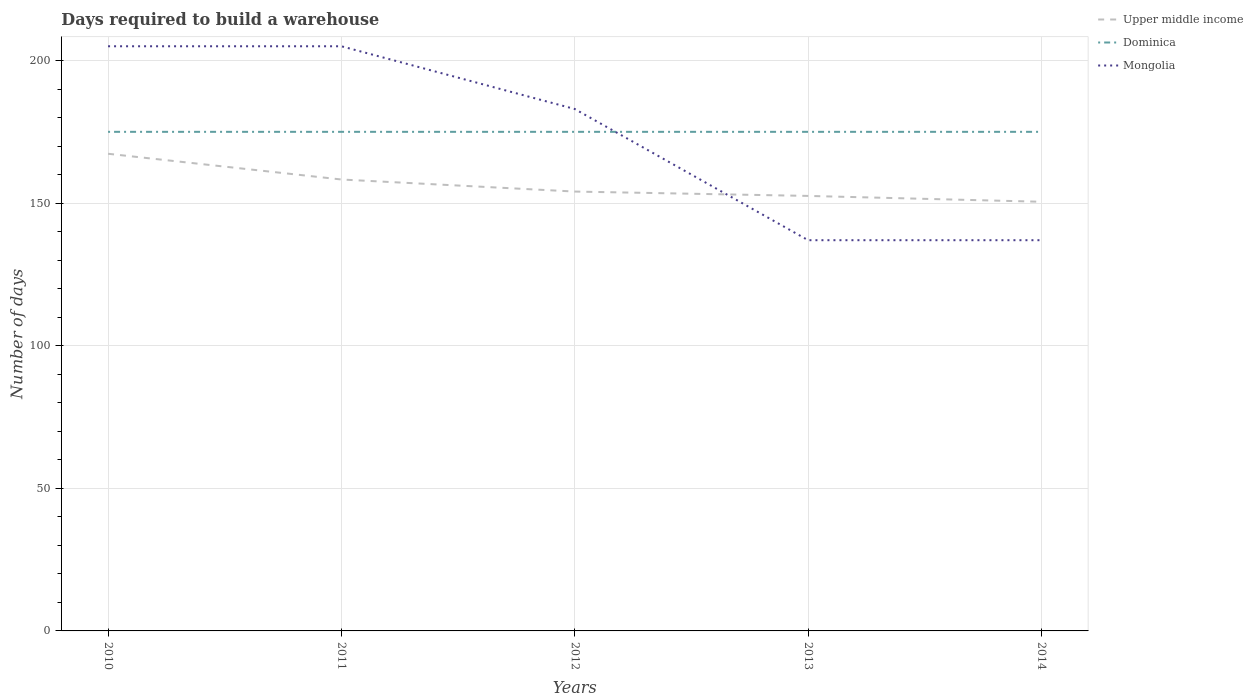How many different coloured lines are there?
Your response must be concise. 3. Does the line corresponding to Upper middle income intersect with the line corresponding to Mongolia?
Offer a terse response. Yes. Is the number of lines equal to the number of legend labels?
Keep it short and to the point. Yes. Across all years, what is the maximum days required to build a warehouse in in Upper middle income?
Give a very brief answer. 150.48. What is the total days required to build a warehouse in in Mongolia in the graph?
Give a very brief answer. 68. Is the days required to build a warehouse in in Dominica strictly greater than the days required to build a warehouse in in Upper middle income over the years?
Offer a terse response. No. How many lines are there?
Your answer should be very brief. 3. How many years are there in the graph?
Give a very brief answer. 5. What is the difference between two consecutive major ticks on the Y-axis?
Your answer should be compact. 50. Does the graph contain any zero values?
Give a very brief answer. No. Where does the legend appear in the graph?
Your response must be concise. Top right. How many legend labels are there?
Give a very brief answer. 3. How are the legend labels stacked?
Provide a succinct answer. Vertical. What is the title of the graph?
Provide a short and direct response. Days required to build a warehouse. Does "Sub-Saharan Africa (developing only)" appear as one of the legend labels in the graph?
Offer a terse response. No. What is the label or title of the X-axis?
Keep it short and to the point. Years. What is the label or title of the Y-axis?
Offer a very short reply. Number of days. What is the Number of days of Upper middle income in 2010?
Your answer should be very brief. 167.31. What is the Number of days of Dominica in 2010?
Provide a succinct answer. 175. What is the Number of days of Mongolia in 2010?
Your answer should be very brief. 205. What is the Number of days of Upper middle income in 2011?
Provide a short and direct response. 158.28. What is the Number of days in Dominica in 2011?
Give a very brief answer. 175. What is the Number of days of Mongolia in 2011?
Ensure brevity in your answer.  205. What is the Number of days of Upper middle income in 2012?
Your answer should be very brief. 154.06. What is the Number of days in Dominica in 2012?
Provide a succinct answer. 175. What is the Number of days of Mongolia in 2012?
Your answer should be very brief. 183. What is the Number of days of Upper middle income in 2013?
Provide a short and direct response. 152.53. What is the Number of days of Dominica in 2013?
Give a very brief answer. 175. What is the Number of days of Mongolia in 2013?
Offer a very short reply. 137. What is the Number of days of Upper middle income in 2014?
Make the answer very short. 150.48. What is the Number of days in Dominica in 2014?
Your answer should be very brief. 175. What is the Number of days in Mongolia in 2014?
Provide a succinct answer. 137. Across all years, what is the maximum Number of days in Upper middle income?
Your answer should be very brief. 167.31. Across all years, what is the maximum Number of days in Dominica?
Offer a very short reply. 175. Across all years, what is the maximum Number of days of Mongolia?
Offer a very short reply. 205. Across all years, what is the minimum Number of days of Upper middle income?
Offer a terse response. 150.48. Across all years, what is the minimum Number of days in Dominica?
Your answer should be very brief. 175. Across all years, what is the minimum Number of days of Mongolia?
Offer a terse response. 137. What is the total Number of days in Upper middle income in the graph?
Provide a short and direct response. 782.66. What is the total Number of days in Dominica in the graph?
Offer a terse response. 875. What is the total Number of days of Mongolia in the graph?
Your answer should be very brief. 867. What is the difference between the Number of days of Upper middle income in 2010 and that in 2011?
Ensure brevity in your answer.  9.03. What is the difference between the Number of days in Dominica in 2010 and that in 2011?
Make the answer very short. 0. What is the difference between the Number of days in Mongolia in 2010 and that in 2011?
Offer a terse response. 0. What is the difference between the Number of days in Upper middle income in 2010 and that in 2012?
Give a very brief answer. 13.25. What is the difference between the Number of days in Dominica in 2010 and that in 2012?
Provide a succinct answer. 0. What is the difference between the Number of days of Mongolia in 2010 and that in 2012?
Your response must be concise. 22. What is the difference between the Number of days in Upper middle income in 2010 and that in 2013?
Provide a short and direct response. 14.78. What is the difference between the Number of days of Upper middle income in 2010 and that in 2014?
Give a very brief answer. 16.83. What is the difference between the Number of days in Mongolia in 2010 and that in 2014?
Give a very brief answer. 68. What is the difference between the Number of days in Upper middle income in 2011 and that in 2012?
Offer a very short reply. 4.23. What is the difference between the Number of days of Dominica in 2011 and that in 2012?
Your answer should be compact. 0. What is the difference between the Number of days of Upper middle income in 2011 and that in 2013?
Provide a succinct answer. 5.75. What is the difference between the Number of days in Mongolia in 2011 and that in 2013?
Ensure brevity in your answer.  68. What is the difference between the Number of days in Upper middle income in 2011 and that in 2014?
Offer a terse response. 7.81. What is the difference between the Number of days of Dominica in 2011 and that in 2014?
Your answer should be compact. 0. What is the difference between the Number of days of Mongolia in 2011 and that in 2014?
Your answer should be very brief. 68. What is the difference between the Number of days in Upper middle income in 2012 and that in 2013?
Your answer should be very brief. 1.53. What is the difference between the Number of days in Dominica in 2012 and that in 2013?
Keep it short and to the point. 0. What is the difference between the Number of days in Mongolia in 2012 and that in 2013?
Provide a succinct answer. 46. What is the difference between the Number of days of Upper middle income in 2012 and that in 2014?
Offer a terse response. 3.58. What is the difference between the Number of days of Dominica in 2012 and that in 2014?
Ensure brevity in your answer.  0. What is the difference between the Number of days in Upper middle income in 2013 and that in 2014?
Keep it short and to the point. 2.05. What is the difference between the Number of days in Dominica in 2013 and that in 2014?
Your answer should be compact. 0. What is the difference between the Number of days of Mongolia in 2013 and that in 2014?
Your answer should be compact. 0. What is the difference between the Number of days in Upper middle income in 2010 and the Number of days in Dominica in 2011?
Your answer should be compact. -7.69. What is the difference between the Number of days in Upper middle income in 2010 and the Number of days in Mongolia in 2011?
Keep it short and to the point. -37.69. What is the difference between the Number of days in Dominica in 2010 and the Number of days in Mongolia in 2011?
Your answer should be very brief. -30. What is the difference between the Number of days of Upper middle income in 2010 and the Number of days of Dominica in 2012?
Your response must be concise. -7.69. What is the difference between the Number of days of Upper middle income in 2010 and the Number of days of Mongolia in 2012?
Make the answer very short. -15.69. What is the difference between the Number of days in Upper middle income in 2010 and the Number of days in Dominica in 2013?
Offer a very short reply. -7.69. What is the difference between the Number of days of Upper middle income in 2010 and the Number of days of Mongolia in 2013?
Your response must be concise. 30.31. What is the difference between the Number of days in Dominica in 2010 and the Number of days in Mongolia in 2013?
Your answer should be compact. 38. What is the difference between the Number of days of Upper middle income in 2010 and the Number of days of Dominica in 2014?
Provide a short and direct response. -7.69. What is the difference between the Number of days in Upper middle income in 2010 and the Number of days in Mongolia in 2014?
Your answer should be very brief. 30.31. What is the difference between the Number of days in Upper middle income in 2011 and the Number of days in Dominica in 2012?
Your answer should be compact. -16.72. What is the difference between the Number of days of Upper middle income in 2011 and the Number of days of Mongolia in 2012?
Keep it short and to the point. -24.72. What is the difference between the Number of days of Upper middle income in 2011 and the Number of days of Dominica in 2013?
Provide a succinct answer. -16.72. What is the difference between the Number of days in Upper middle income in 2011 and the Number of days in Mongolia in 2013?
Your response must be concise. 21.28. What is the difference between the Number of days of Upper middle income in 2011 and the Number of days of Dominica in 2014?
Make the answer very short. -16.72. What is the difference between the Number of days in Upper middle income in 2011 and the Number of days in Mongolia in 2014?
Your answer should be very brief. 21.28. What is the difference between the Number of days of Upper middle income in 2012 and the Number of days of Dominica in 2013?
Give a very brief answer. -20.94. What is the difference between the Number of days in Upper middle income in 2012 and the Number of days in Mongolia in 2013?
Offer a terse response. 17.06. What is the difference between the Number of days of Upper middle income in 2012 and the Number of days of Dominica in 2014?
Keep it short and to the point. -20.94. What is the difference between the Number of days in Upper middle income in 2012 and the Number of days in Mongolia in 2014?
Your answer should be very brief. 17.06. What is the difference between the Number of days in Upper middle income in 2013 and the Number of days in Dominica in 2014?
Your answer should be very brief. -22.47. What is the difference between the Number of days in Upper middle income in 2013 and the Number of days in Mongolia in 2014?
Ensure brevity in your answer.  15.53. What is the average Number of days of Upper middle income per year?
Provide a succinct answer. 156.53. What is the average Number of days in Dominica per year?
Give a very brief answer. 175. What is the average Number of days in Mongolia per year?
Offer a very short reply. 173.4. In the year 2010, what is the difference between the Number of days of Upper middle income and Number of days of Dominica?
Keep it short and to the point. -7.69. In the year 2010, what is the difference between the Number of days of Upper middle income and Number of days of Mongolia?
Your answer should be compact. -37.69. In the year 2011, what is the difference between the Number of days in Upper middle income and Number of days in Dominica?
Give a very brief answer. -16.72. In the year 2011, what is the difference between the Number of days of Upper middle income and Number of days of Mongolia?
Offer a very short reply. -46.72. In the year 2011, what is the difference between the Number of days in Dominica and Number of days in Mongolia?
Keep it short and to the point. -30. In the year 2012, what is the difference between the Number of days of Upper middle income and Number of days of Dominica?
Provide a short and direct response. -20.94. In the year 2012, what is the difference between the Number of days of Upper middle income and Number of days of Mongolia?
Offer a terse response. -28.94. In the year 2012, what is the difference between the Number of days in Dominica and Number of days in Mongolia?
Provide a succinct answer. -8. In the year 2013, what is the difference between the Number of days of Upper middle income and Number of days of Dominica?
Provide a succinct answer. -22.47. In the year 2013, what is the difference between the Number of days in Upper middle income and Number of days in Mongolia?
Keep it short and to the point. 15.53. In the year 2013, what is the difference between the Number of days in Dominica and Number of days in Mongolia?
Your answer should be very brief. 38. In the year 2014, what is the difference between the Number of days in Upper middle income and Number of days in Dominica?
Provide a succinct answer. -24.52. In the year 2014, what is the difference between the Number of days in Upper middle income and Number of days in Mongolia?
Provide a short and direct response. 13.48. What is the ratio of the Number of days of Upper middle income in 2010 to that in 2011?
Offer a terse response. 1.06. What is the ratio of the Number of days of Upper middle income in 2010 to that in 2012?
Ensure brevity in your answer.  1.09. What is the ratio of the Number of days of Dominica in 2010 to that in 2012?
Offer a terse response. 1. What is the ratio of the Number of days of Mongolia in 2010 to that in 2012?
Offer a very short reply. 1.12. What is the ratio of the Number of days of Upper middle income in 2010 to that in 2013?
Offer a very short reply. 1.1. What is the ratio of the Number of days of Dominica in 2010 to that in 2013?
Ensure brevity in your answer.  1. What is the ratio of the Number of days in Mongolia in 2010 to that in 2013?
Your answer should be very brief. 1.5. What is the ratio of the Number of days in Upper middle income in 2010 to that in 2014?
Your answer should be very brief. 1.11. What is the ratio of the Number of days in Dominica in 2010 to that in 2014?
Keep it short and to the point. 1. What is the ratio of the Number of days in Mongolia in 2010 to that in 2014?
Keep it short and to the point. 1.5. What is the ratio of the Number of days in Upper middle income in 2011 to that in 2012?
Your answer should be very brief. 1.03. What is the ratio of the Number of days in Dominica in 2011 to that in 2012?
Ensure brevity in your answer.  1. What is the ratio of the Number of days of Mongolia in 2011 to that in 2012?
Offer a very short reply. 1.12. What is the ratio of the Number of days in Upper middle income in 2011 to that in 2013?
Provide a short and direct response. 1.04. What is the ratio of the Number of days of Dominica in 2011 to that in 2013?
Offer a very short reply. 1. What is the ratio of the Number of days of Mongolia in 2011 to that in 2013?
Your answer should be compact. 1.5. What is the ratio of the Number of days of Upper middle income in 2011 to that in 2014?
Offer a terse response. 1.05. What is the ratio of the Number of days of Dominica in 2011 to that in 2014?
Ensure brevity in your answer.  1. What is the ratio of the Number of days in Mongolia in 2011 to that in 2014?
Ensure brevity in your answer.  1.5. What is the ratio of the Number of days of Upper middle income in 2012 to that in 2013?
Your answer should be compact. 1.01. What is the ratio of the Number of days in Mongolia in 2012 to that in 2013?
Make the answer very short. 1.34. What is the ratio of the Number of days of Upper middle income in 2012 to that in 2014?
Offer a very short reply. 1.02. What is the ratio of the Number of days of Mongolia in 2012 to that in 2014?
Keep it short and to the point. 1.34. What is the ratio of the Number of days in Upper middle income in 2013 to that in 2014?
Provide a short and direct response. 1.01. What is the ratio of the Number of days of Dominica in 2013 to that in 2014?
Provide a succinct answer. 1. What is the ratio of the Number of days in Mongolia in 2013 to that in 2014?
Keep it short and to the point. 1. What is the difference between the highest and the second highest Number of days in Upper middle income?
Offer a very short reply. 9.03. What is the difference between the highest and the second highest Number of days in Dominica?
Give a very brief answer. 0. What is the difference between the highest and the second highest Number of days in Mongolia?
Give a very brief answer. 0. What is the difference between the highest and the lowest Number of days of Upper middle income?
Your response must be concise. 16.83. What is the difference between the highest and the lowest Number of days of Dominica?
Provide a short and direct response. 0. 